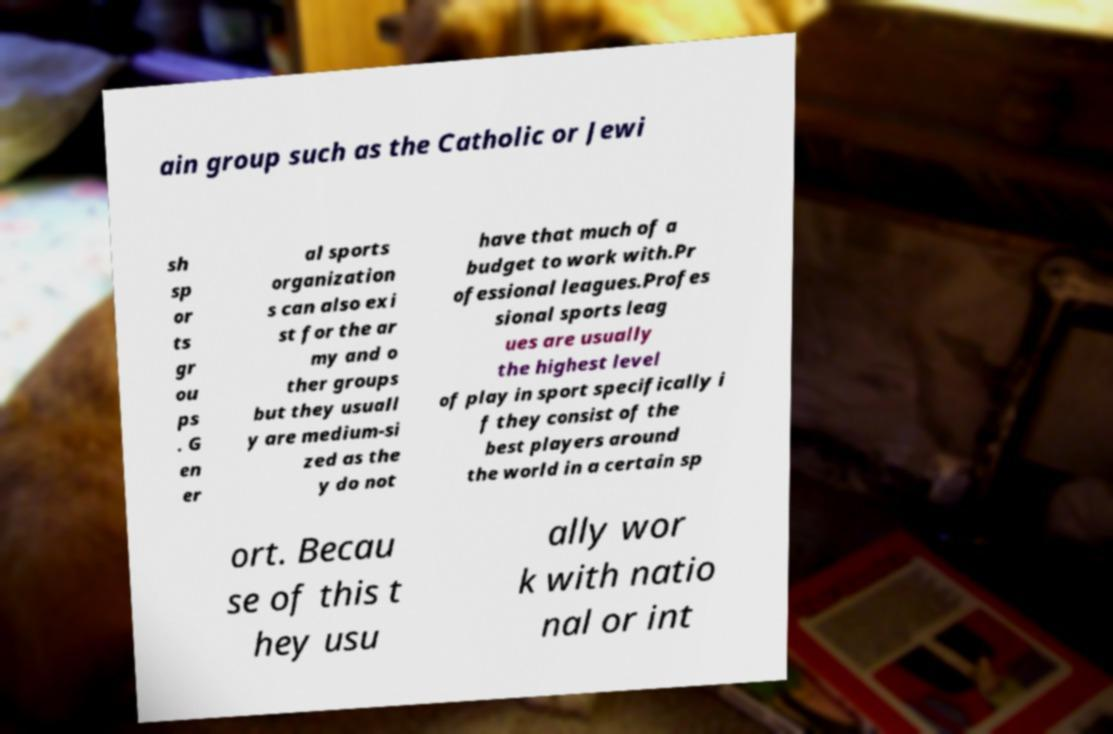Please read and relay the text visible in this image. What does it say? ain group such as the Catholic or Jewi sh sp or ts gr ou ps . G en er al sports organization s can also exi st for the ar my and o ther groups but they usuall y are medium-si zed as the y do not have that much of a budget to work with.Pr ofessional leagues.Profes sional sports leag ues are usually the highest level of play in sport specifically i f they consist of the best players around the world in a certain sp ort. Becau se of this t hey usu ally wor k with natio nal or int 